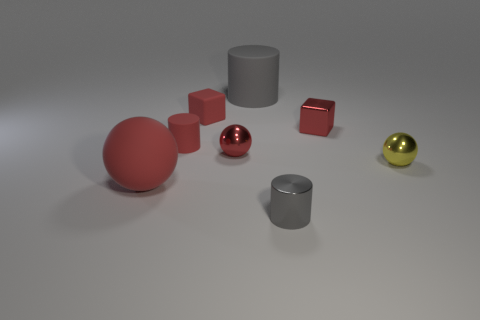What is the size of the matte cylinder that is on the right side of the red rubber cube behind the large matte sphere that is on the left side of the small red ball?
Offer a terse response. Large. The object that is left of the metal cylinder and in front of the small yellow shiny ball is what color?
Offer a terse response. Red. There is a cylinder in front of the red matte sphere; what size is it?
Your answer should be compact. Small. How many other small gray cylinders have the same material as the tiny gray cylinder?
Offer a very short reply. 0. What shape is the tiny metal object that is the same color as the large rubber cylinder?
Ensure brevity in your answer.  Cylinder. Is the shape of the red rubber object in front of the yellow metal sphere the same as  the yellow metal object?
Offer a terse response. Yes. The cube that is the same material as the small yellow object is what color?
Your response must be concise. Red. There is a tiny red cube to the left of the gray cylinder behind the matte block; is there a small yellow thing behind it?
Keep it short and to the point. No. There is a yellow object; what shape is it?
Your response must be concise. Sphere. Is the number of yellow metallic balls to the left of the big matte sphere less than the number of purple things?
Offer a very short reply. No. 